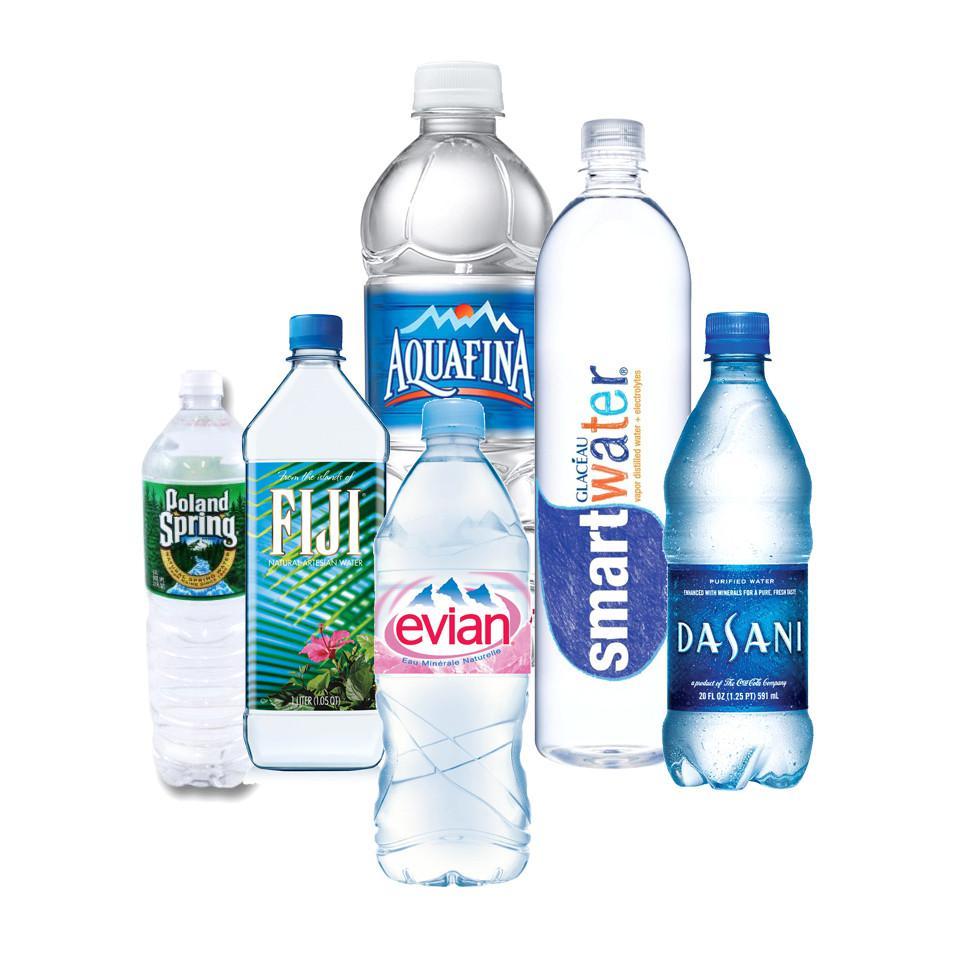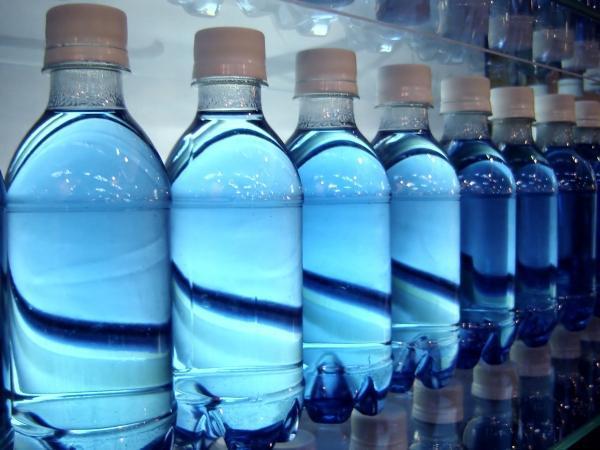The first image is the image on the left, the second image is the image on the right. Analyze the images presented: Is the assertion "The bottles in one image clearly have labels, the bottles in the other clearly do not." valid? Answer yes or no. Yes. The first image is the image on the left, the second image is the image on the right. Assess this claim about the two images: "One image shows a row of water bottles with white caps and no labels, and the other image shows a variety of water bottle shapes and labels in an overlapping arrangement.". Correct or not? Answer yes or no. Yes. 